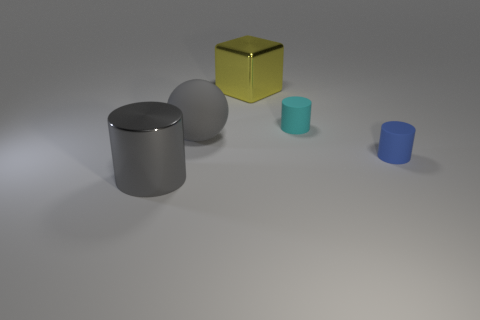Is the color of the big ball the same as the big metal cylinder?
Give a very brief answer. Yes. There is a thing that is both in front of the gray rubber ball and on the left side of the large metallic block; what is its material?
Keep it short and to the point. Metal. Are there the same number of large metallic objects on the right side of the big cylinder and matte things behind the big yellow metallic object?
Offer a very short reply. No. What number of cubes are either tiny blue objects or large things?
Your response must be concise. 1. What number of other objects are the same material as the large gray sphere?
Your answer should be compact. 2. What is the shape of the large object that is left of the gray matte object?
Your response must be concise. Cylinder. What material is the big gray thing right of the metallic thing to the left of the yellow shiny object?
Offer a terse response. Rubber. Are there more gray balls on the right side of the metal block than yellow objects?
Ensure brevity in your answer.  No. How many other objects are there of the same color as the big matte sphere?
Keep it short and to the point. 1. There is a metal object that is the same size as the block; what is its shape?
Ensure brevity in your answer.  Cylinder. 